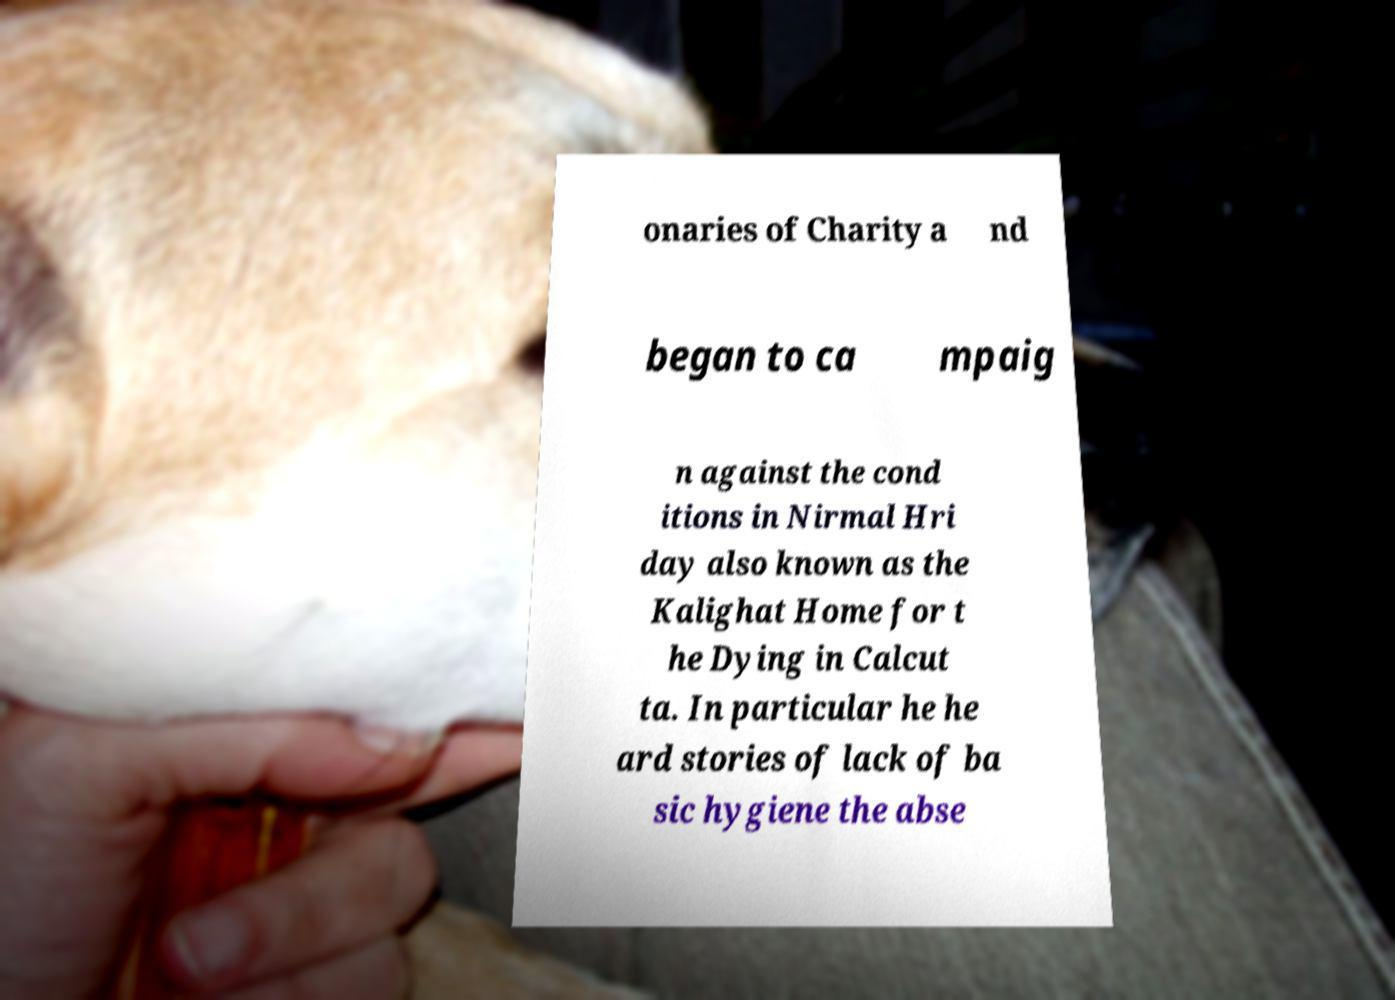Can you read and provide the text displayed in the image?This photo seems to have some interesting text. Can you extract and type it out for me? onaries of Charity a nd began to ca mpaig n against the cond itions in Nirmal Hri day also known as the Kalighat Home for t he Dying in Calcut ta. In particular he he ard stories of lack of ba sic hygiene the abse 